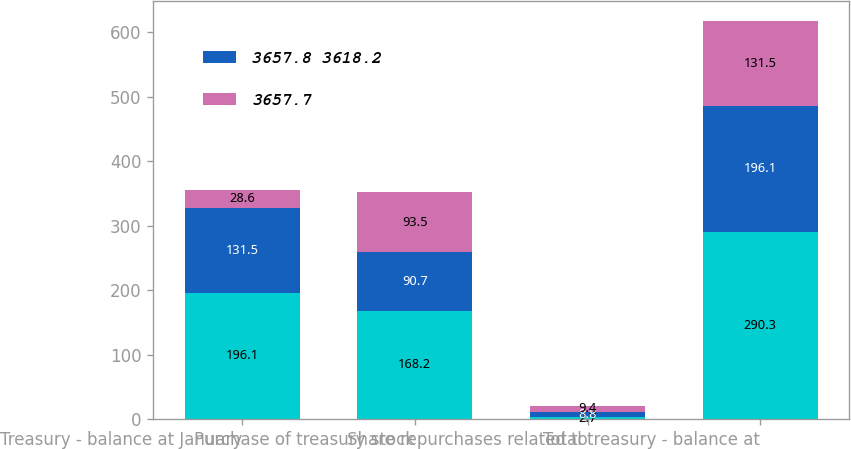Convert chart to OTSL. <chart><loc_0><loc_0><loc_500><loc_500><stacked_bar_chart><ecel><fcel>Treasury - balance at January<fcel>Purchase of treasury stock<fcel>Share repurchases related to<fcel>Total treasury - balance at<nl><fcel>nan<fcel>196.1<fcel>168.2<fcel>2.7<fcel>290.3<nl><fcel>3657.8 3618.2<fcel>131.5<fcel>90.7<fcel>8.8<fcel>196.1<nl><fcel>3657.7<fcel>28.6<fcel>93.5<fcel>9.4<fcel>131.5<nl></chart> 